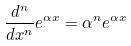<formula> <loc_0><loc_0><loc_500><loc_500>\frac { d ^ { n } } { d x ^ { n } } e ^ { \alpha x } = \alpha ^ { n } e ^ { \alpha x }</formula> 